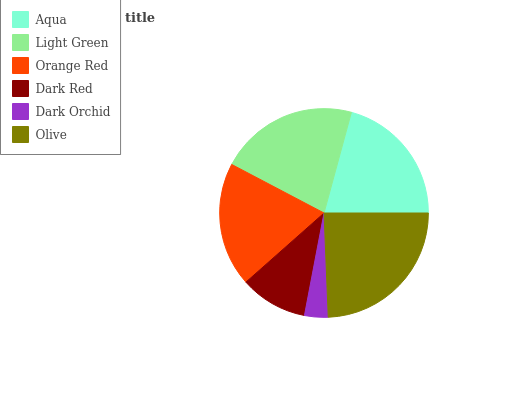Is Dark Orchid the minimum?
Answer yes or no. Yes. Is Olive the maximum?
Answer yes or no. Yes. Is Light Green the minimum?
Answer yes or no. No. Is Light Green the maximum?
Answer yes or no. No. Is Light Green greater than Aqua?
Answer yes or no. Yes. Is Aqua less than Light Green?
Answer yes or no. Yes. Is Aqua greater than Light Green?
Answer yes or no. No. Is Light Green less than Aqua?
Answer yes or no. No. Is Aqua the high median?
Answer yes or no. Yes. Is Orange Red the low median?
Answer yes or no. Yes. Is Olive the high median?
Answer yes or no. No. Is Olive the low median?
Answer yes or no. No. 